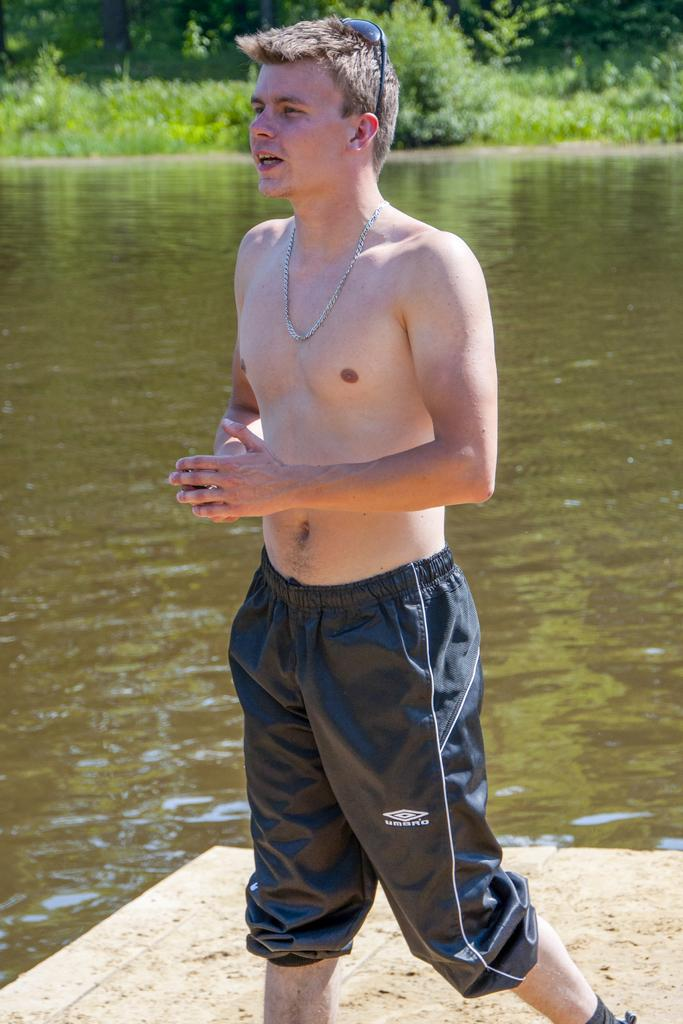What is the main subject of the image? There is a man standing in the image. Can you describe the man's attire? The man is not wearing a shirt. What can be seen in the background of the image? There is water visible in the background of the image. Are there any plants near the water in the background? Yes, there are small plants near the water in the background. What type of jam is the man spreading on the yak in the image? There is no jam or yak present in the image; it features a man standing without a shirt and a background with water and small plants. 